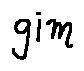<formula> <loc_0><loc_0><loc_500><loc_500>g i m</formula> 